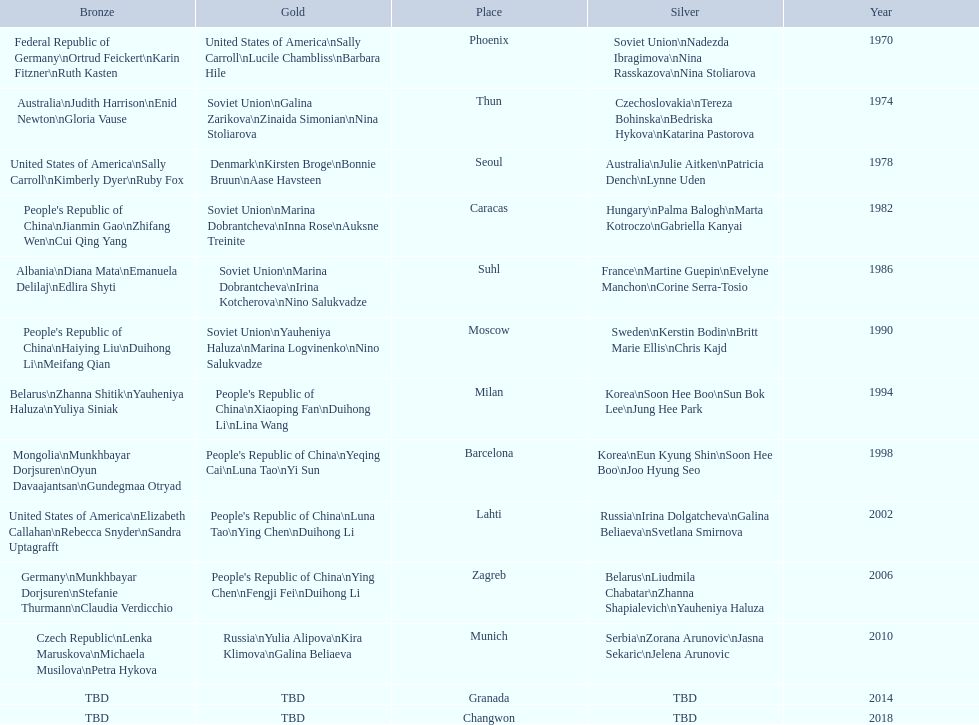How many world championships had the soviet union won first place in in the 25 metre pistol women's world championship? 4. 